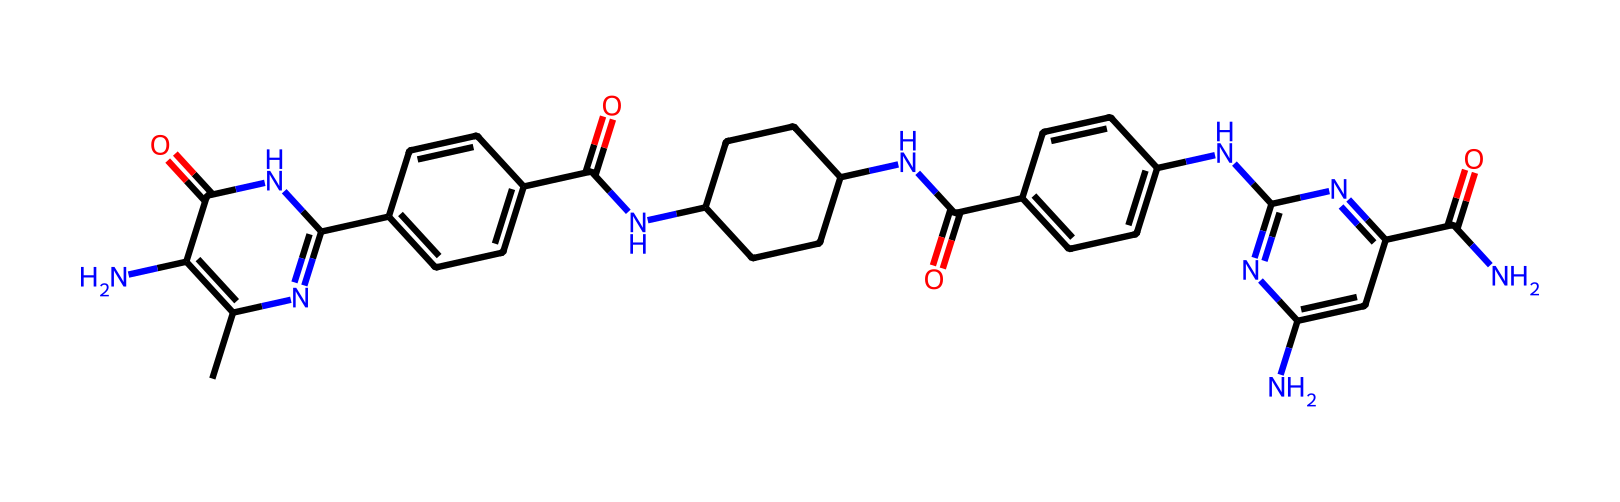What is the molecular formula of this compound? Analyzing the provided SMILES, we can identify the specific atoms present: carbons (C), hydrogens (H), nitrogens (N), and oxygens (O). Counting each type of atom gives us the empirical formula.
Answer: C22H30N8O6 How many nitrogen atoms are present in this molecule? Counting the nitrogen atoms (N) in the chemical structure derived from the SMILES reveals a total of 8 nitrogen atoms.
Answer: 8 What type of biochemical is represented by this structure? This compound, analyzed through its functional groups and structure, is categorized as a peptide or amino acid derivative due to the presence of multiple amide bonds and amino-like characteristics.
Answer: peptide Which parts of this molecule are responsible for oxygen transport? Hemoglobin's functionality relies on iron-containing heme groups, which facilitate oxygen binding. Although this is not hemoglobin, the resemblance to peptide structures indicates that similar heme components might contribute to analogous functionalities.
Answer: heme groups Does this compound exhibit potential for medicinal properties? On evaluating the structure for features commonly associated with medicinal activity, such as the presence of heterocycles and multiple nitrogen-containing groups, it can be inferred that this structural complexity hints at potential bioactivity, a hallmark of many pharmaceuticals.
Answer: yes What functional groups are prominent in this chemical composition? Dissecting the structure reveals a series of amide (C(=O)N), ketone (C=O), and aromatic ring functionalities, which provide insight into the reactivity and biological interactions of the compound.
Answer: amide, ketone, aromatic 